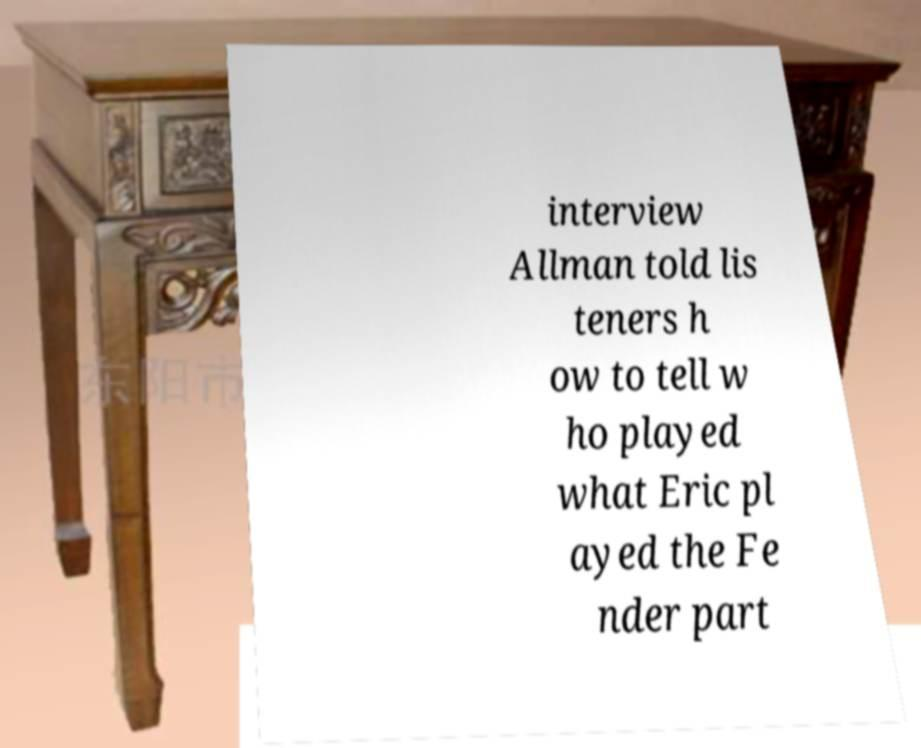Please identify and transcribe the text found in this image. interview Allman told lis teners h ow to tell w ho played what Eric pl ayed the Fe nder part 